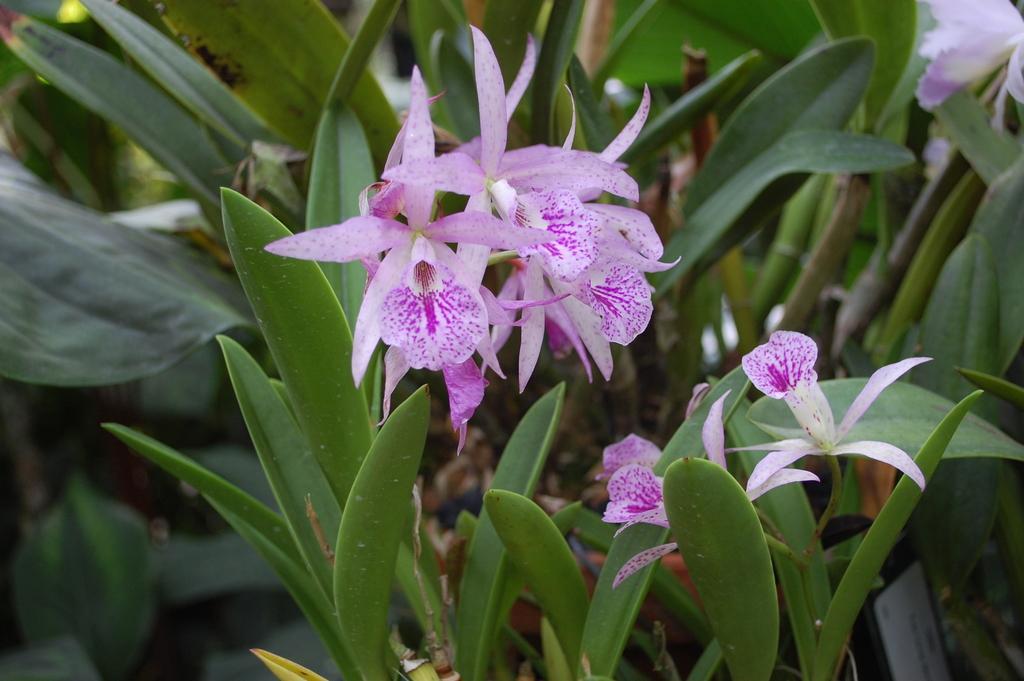Please provide a concise description of this image. In this picture we can see some flowers and a few green plants in the background. There is an object visible on the right side. 